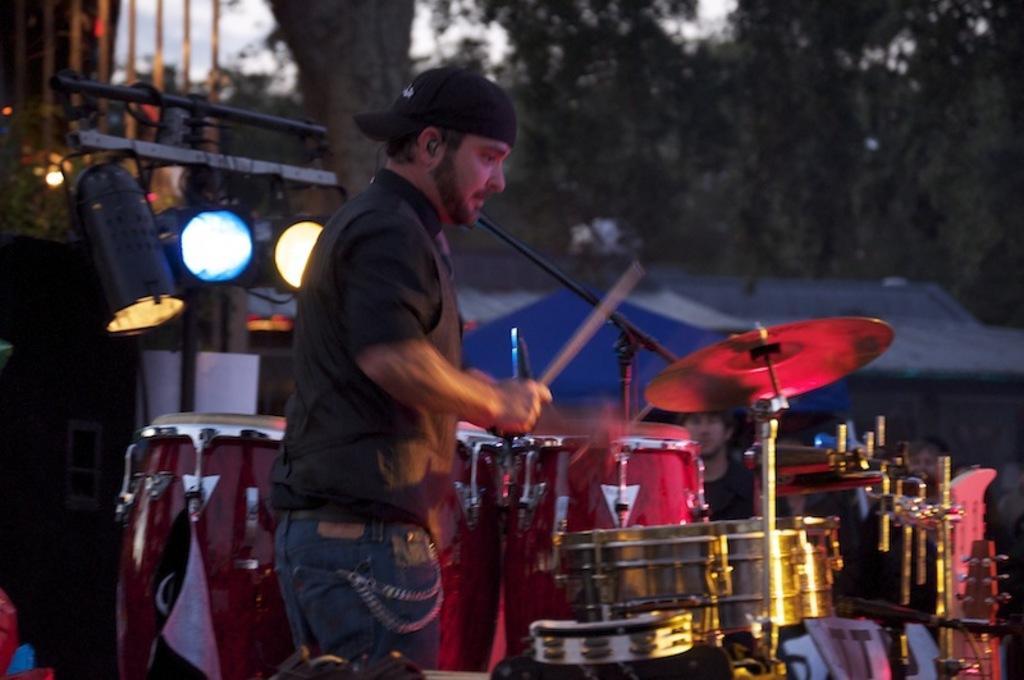Can you describe this image briefly? In this picture there is a man who is wearing a black shirt and a black cap. He is playing a drum. There is a light at the background. There is a tree at the background. To the right there are few people standing. 